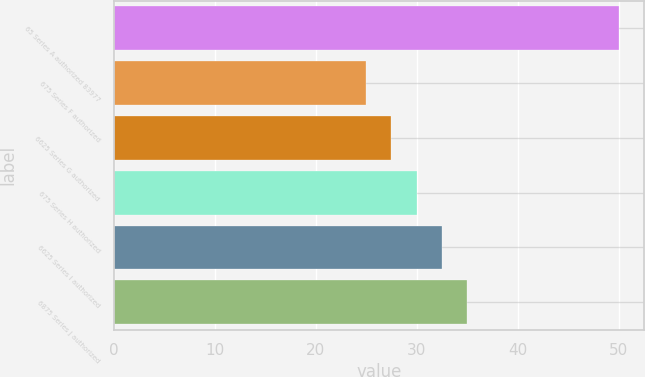Convert chart. <chart><loc_0><loc_0><loc_500><loc_500><bar_chart><fcel>65 Series A authorized 83977<fcel>675 Series F authorized<fcel>6625 Series G authorized<fcel>675 Series H authorized<fcel>6625 Series I authorized<fcel>6875 Series J authorized<nl><fcel>50<fcel>25<fcel>27.5<fcel>30<fcel>32.5<fcel>35<nl></chart> 